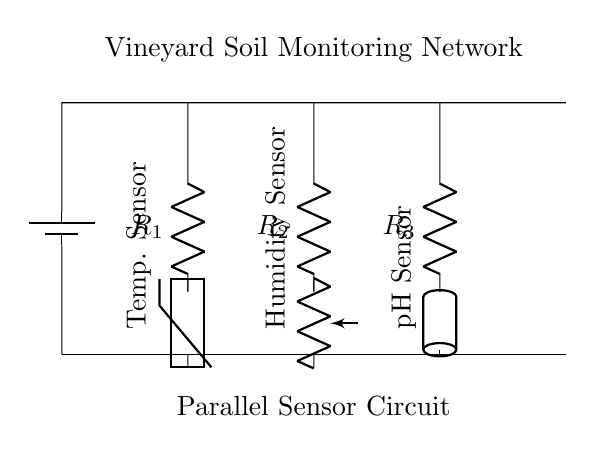What type of circuit is shown in the diagram? The diagram represents a parallel circuit, where multiple components connect across the same voltage source, allowing for independent current paths.
Answer: Parallel How many sensors are in the circuit? There are three sensors indicated in the circuit diagram, each monitoring different soil conditions (temperature, humidity, pH).
Answer: Three What is the role of the thermistor in the diagram? The thermistor is a temperature sensor that varies its resistance according to the temperature of the soil, providing data about the environmental conditions.
Answer: Temperature sensor What is the purpose of resistors R1, R2, and R3 in the circuit? The resistors R1, R2, and R3 are in series with their respective sensors, and they help limit current to protect the sensors and optimize the readings from them.
Answer: Current limiting How does the parallel circuit configuration benefit the sensor network? The parallel configuration allows each sensor to operate independently, ensuring that the failure of one sensor does not affect the operation of the others and that they all receive the same voltage from the battery.
Answer: Independent operation What voltage is provided to the sensors in this circuit? The sensors receive the same voltage as supplied by the battery, which is shown at the top of the circuit.
Answer: Battery voltage 